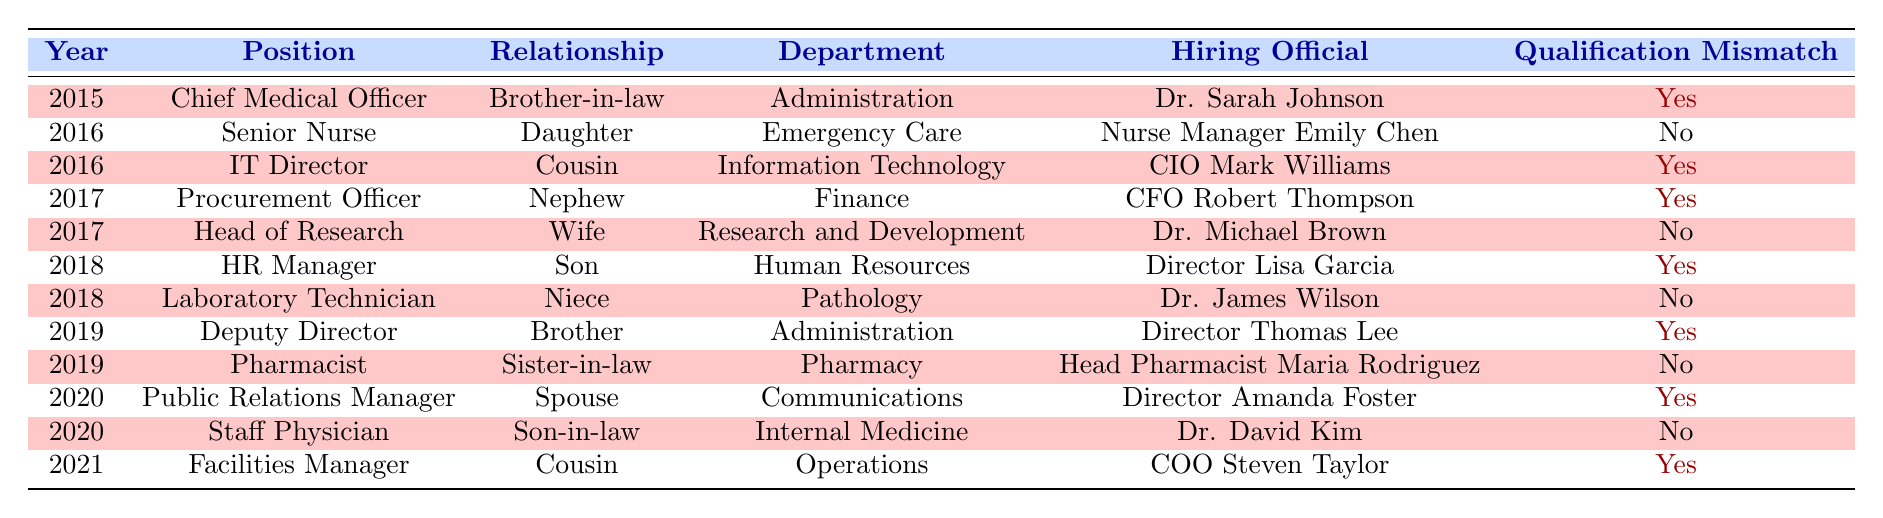What positions had qualification mismatches in 2018? In 2018, there were two positions listed: HR Manager (with a qualification mismatch) and Laboratory Technician (without a qualification mismatch). Therefore, only HR Manager had a qualification mismatch.
Answer: HR Manager How many total nepotism cases occurred in 2016? In 2016, there were two positions listed: Senior Nurse and IT Director. Therefore, the total number of nepotism cases for that year is 2.
Answer: 2 Was there any hiring official involved in nepotism cases in both 2017 and 2019? In 2017, Dr. Michael Brown and CFO Robert Thompson were hiring officials, while in 2019, Director Thomas Lee and Head Pharmacist Maria Rodriguez were hiring officials. None of the hiring officials from both years overlap.
Answer: No In which years did the hiring officials have qualification mismatches for positions they hired? The years with qualification mismatches are 2015, 2016, 2017, 2018, 2019, 2020, and 2021. Each of these years had at least one position where a hiring official hired someone with a qualification mismatch.
Answer: 2015, 2016, 2017, 2018, 2019, 2020, 2021 How many total hiring positions had a spousal relationship to the hiring official and had a qualification mismatch? There is only one instance where a hire was related as a spouse (Public Relations Manager in 2020) and that hire also had a qualification mismatch. Hence, the total is 1.
Answer: 1 